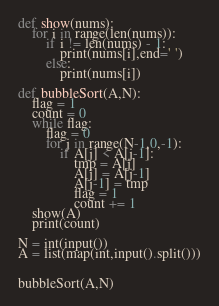<code> <loc_0><loc_0><loc_500><loc_500><_Python_>def show(nums):
    for i in range(len(nums)):
        if i != len(nums) - 1:
            print(nums[i],end=' ')
        else:
            print(nums[i])

def bubbleSort(A,N):
    flag = 1
    count = 0
    while flag:
        flag = 0
        for j in range(N-1,0,-1):
            if A[j] < A[j-1]:
                tmp = A[j]
                A[j] = A[j-1]
                A[j-1] = tmp
                flag = 1
                count += 1
    show(A)
    print(count)

N = int(input())
A = list(map(int,input().split()))


bubbleSort(A,N)

</code> 